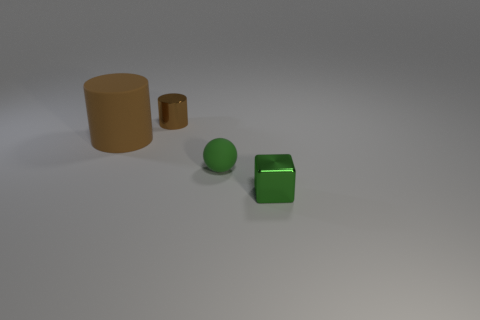What is the size of the rubber object right of the small brown cylinder?
Ensure brevity in your answer.  Small. How many green metallic blocks are the same size as the matte ball?
Keep it short and to the point. 1. What is the color of the other thing that is the same material as the large thing?
Give a very brief answer. Green. Are there fewer brown cylinders in front of the tiny ball than green rubber things?
Provide a short and direct response. Yes. There is a tiny thing that is made of the same material as the block; what is its shape?
Your response must be concise. Cylinder. How many shiny objects are green objects or yellow cylinders?
Give a very brief answer. 1. Is the number of tiny green objects behind the tiny green rubber sphere the same as the number of matte spheres?
Keep it short and to the point. No. There is a shiny thing in front of the big brown matte object; does it have the same color as the shiny cylinder?
Provide a succinct answer. No. What material is the thing that is to the left of the green ball and on the right side of the brown matte cylinder?
Offer a terse response. Metal. Is there a brown rubber thing to the right of the matte thing that is on the left side of the metallic cylinder?
Offer a terse response. No. 